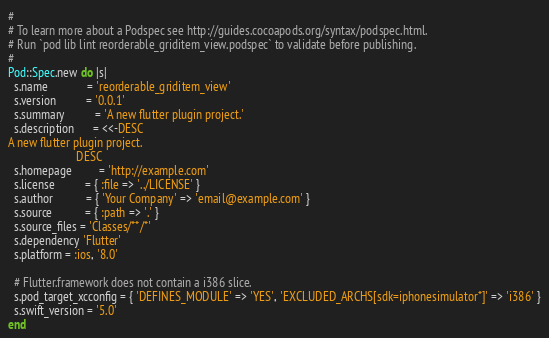Convert code to text. <code><loc_0><loc_0><loc_500><loc_500><_Ruby_>#
# To learn more about a Podspec see http://guides.cocoapods.org/syntax/podspec.html.
# Run `pod lib lint reorderable_griditem_view.podspec` to validate before publishing.
#
Pod::Spec.new do |s|
  s.name             = 'reorderable_griditem_view'
  s.version          = '0.0.1'
  s.summary          = 'A new flutter plugin project.'
  s.description      = <<-DESC
A new flutter plugin project.
                       DESC
  s.homepage         = 'http://example.com'
  s.license          = { :file => '../LICENSE' }
  s.author           = { 'Your Company' => 'email@example.com' }
  s.source           = { :path => '.' }
  s.source_files = 'Classes/**/*'
  s.dependency 'Flutter'
  s.platform = :ios, '8.0'

  # Flutter.framework does not contain a i386 slice.
  s.pod_target_xcconfig = { 'DEFINES_MODULE' => 'YES', 'EXCLUDED_ARCHS[sdk=iphonesimulator*]' => 'i386' }
  s.swift_version = '5.0'
end
</code> 